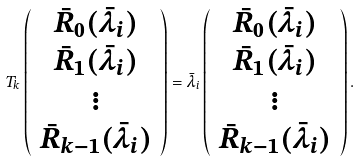Convert formula to latex. <formula><loc_0><loc_0><loc_500><loc_500>T _ { k } \left ( \begin{array} { c } \bar { R } _ { 0 } ( \bar { \lambda } _ { i } ) \\ \bar { R } _ { 1 } ( \bar { \lambda } _ { i } ) \\ \vdots \\ \bar { R } _ { k - 1 } ( \bar { \lambda } _ { i } ) \\ \end{array} \right ) = \bar { \lambda } _ { i } \left ( \begin{array} { c } \bar { R } _ { 0 } ( \bar { \lambda } _ { i } ) \\ \bar { R } _ { 1 } ( \bar { \lambda } _ { i } ) \\ \vdots \\ \bar { R } _ { k - 1 } ( \bar { \lambda } _ { i } ) \\ \end{array} \right ) .</formula> 